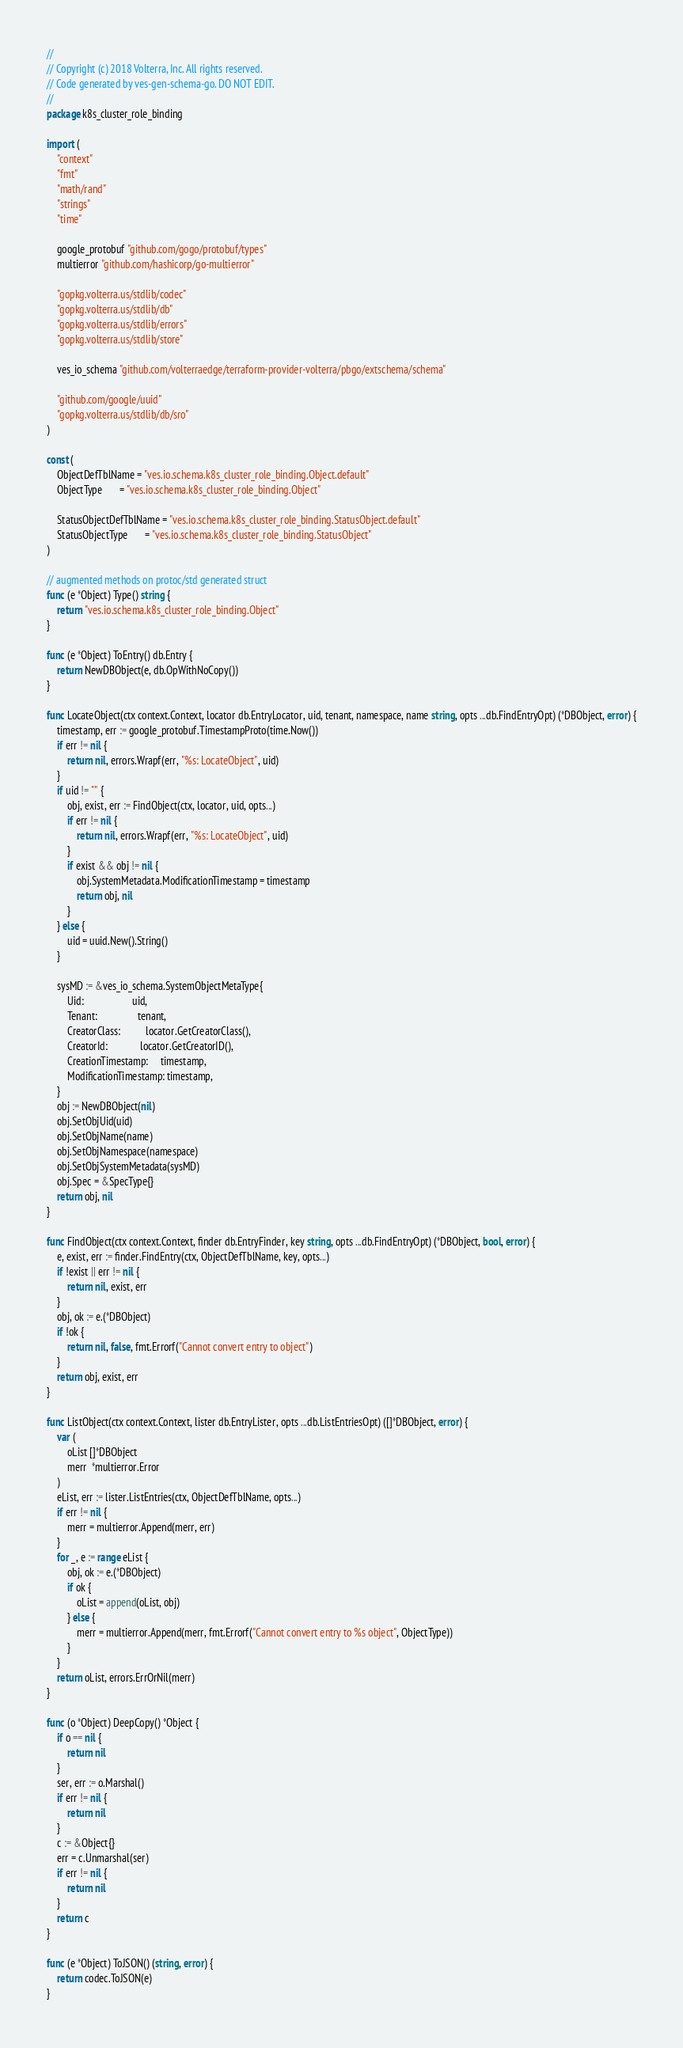<code> <loc_0><loc_0><loc_500><loc_500><_Go_>//
// Copyright (c) 2018 Volterra, Inc. All rights reserved.
// Code generated by ves-gen-schema-go. DO NOT EDIT.
//
package k8s_cluster_role_binding

import (
	"context"
	"fmt"
	"math/rand"
	"strings"
	"time"

	google_protobuf "github.com/gogo/protobuf/types"
	multierror "github.com/hashicorp/go-multierror"

	"gopkg.volterra.us/stdlib/codec"
	"gopkg.volterra.us/stdlib/db"
	"gopkg.volterra.us/stdlib/errors"
	"gopkg.volterra.us/stdlib/store"

	ves_io_schema "github.com/volterraedge/terraform-provider-volterra/pbgo/extschema/schema"

	"github.com/google/uuid"
	"gopkg.volterra.us/stdlib/db/sro"
)

const (
	ObjectDefTblName = "ves.io.schema.k8s_cluster_role_binding.Object.default"
	ObjectType       = "ves.io.schema.k8s_cluster_role_binding.Object"

	StatusObjectDefTblName = "ves.io.schema.k8s_cluster_role_binding.StatusObject.default"
	StatusObjectType       = "ves.io.schema.k8s_cluster_role_binding.StatusObject"
)

// augmented methods on protoc/std generated struct
func (e *Object) Type() string {
	return "ves.io.schema.k8s_cluster_role_binding.Object"
}

func (e *Object) ToEntry() db.Entry {
	return NewDBObject(e, db.OpWithNoCopy())
}

func LocateObject(ctx context.Context, locator db.EntryLocator, uid, tenant, namespace, name string, opts ...db.FindEntryOpt) (*DBObject, error) {
	timestamp, err := google_protobuf.TimestampProto(time.Now())
	if err != nil {
		return nil, errors.Wrapf(err, "%s: LocateObject", uid)
	}
	if uid != "" {
		obj, exist, err := FindObject(ctx, locator, uid, opts...)
		if err != nil {
			return nil, errors.Wrapf(err, "%s: LocateObject", uid)
		}
		if exist && obj != nil {
			obj.SystemMetadata.ModificationTimestamp = timestamp
			return obj, nil
		}
	} else {
		uid = uuid.New().String()
	}

	sysMD := &ves_io_schema.SystemObjectMetaType{
		Uid:                   uid,
		Tenant:                tenant,
		CreatorClass:          locator.GetCreatorClass(),
		CreatorId:             locator.GetCreatorID(),
		CreationTimestamp:     timestamp,
		ModificationTimestamp: timestamp,
	}
	obj := NewDBObject(nil)
	obj.SetObjUid(uid)
	obj.SetObjName(name)
	obj.SetObjNamespace(namespace)
	obj.SetObjSystemMetadata(sysMD)
	obj.Spec = &SpecType{}
	return obj, nil
}

func FindObject(ctx context.Context, finder db.EntryFinder, key string, opts ...db.FindEntryOpt) (*DBObject, bool, error) {
	e, exist, err := finder.FindEntry(ctx, ObjectDefTblName, key, opts...)
	if !exist || err != nil {
		return nil, exist, err
	}
	obj, ok := e.(*DBObject)
	if !ok {
		return nil, false, fmt.Errorf("Cannot convert entry to object")
	}
	return obj, exist, err
}

func ListObject(ctx context.Context, lister db.EntryLister, opts ...db.ListEntriesOpt) ([]*DBObject, error) {
	var (
		oList []*DBObject
		merr  *multierror.Error
	)
	eList, err := lister.ListEntries(ctx, ObjectDefTblName, opts...)
	if err != nil {
		merr = multierror.Append(merr, err)
	}
	for _, e := range eList {
		obj, ok := e.(*DBObject)
		if ok {
			oList = append(oList, obj)
		} else {
			merr = multierror.Append(merr, fmt.Errorf("Cannot convert entry to %s object", ObjectType))
		}
	}
	return oList, errors.ErrOrNil(merr)
}

func (o *Object) DeepCopy() *Object {
	if o == nil {
		return nil
	}
	ser, err := o.Marshal()
	if err != nil {
		return nil
	}
	c := &Object{}
	err = c.Unmarshal(ser)
	if err != nil {
		return nil
	}
	return c
}

func (e *Object) ToJSON() (string, error) {
	return codec.ToJSON(e)
}
</code> 